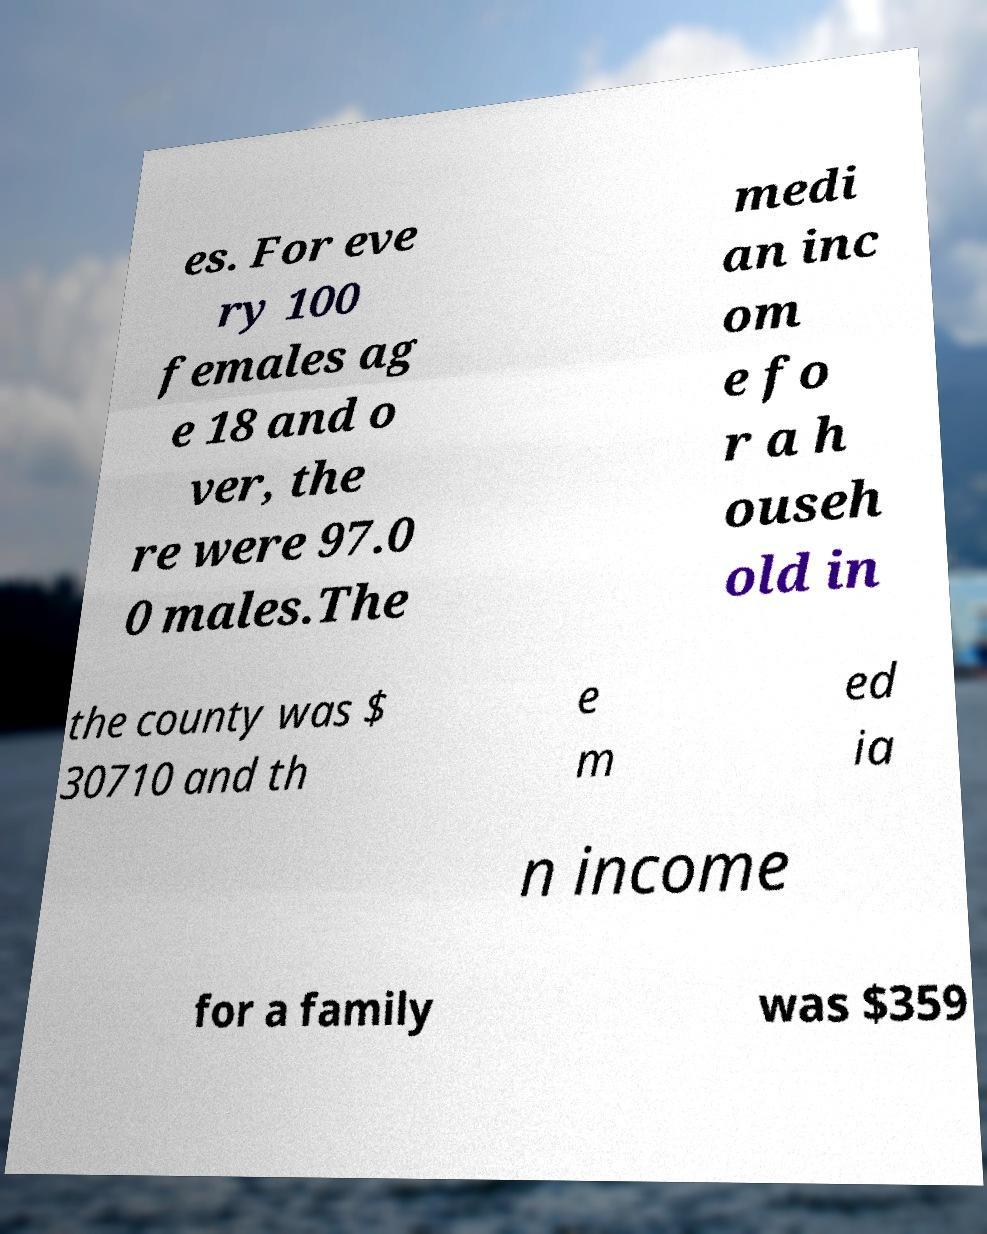What messages or text are displayed in this image? I need them in a readable, typed format. es. For eve ry 100 females ag e 18 and o ver, the re were 97.0 0 males.The medi an inc om e fo r a h ouseh old in the county was $ 30710 and th e m ed ia n income for a family was $359 